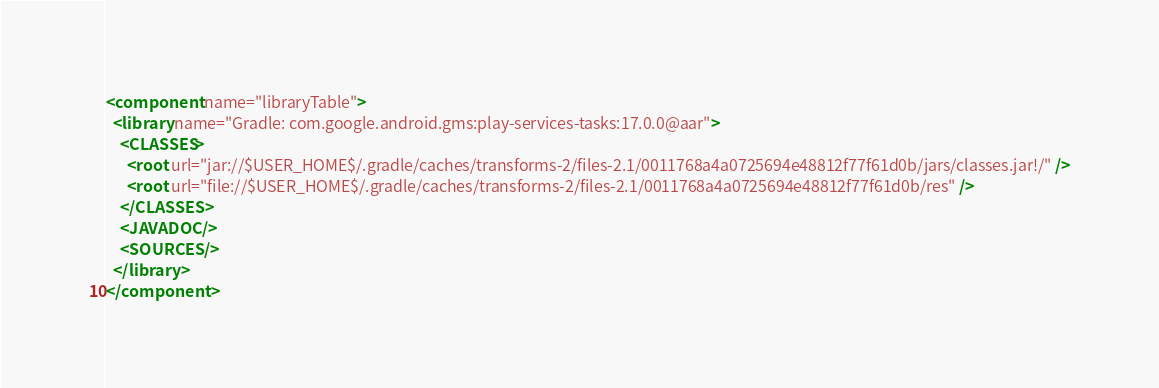Convert code to text. <code><loc_0><loc_0><loc_500><loc_500><_XML_><component name="libraryTable">
  <library name="Gradle: com.google.android.gms:play-services-tasks:17.0.0@aar">
    <CLASSES>
      <root url="jar://$USER_HOME$/.gradle/caches/transforms-2/files-2.1/0011768a4a0725694e48812f77f61d0b/jars/classes.jar!/" />
      <root url="file://$USER_HOME$/.gradle/caches/transforms-2/files-2.1/0011768a4a0725694e48812f77f61d0b/res" />
    </CLASSES>
    <JAVADOC />
    <SOURCES />
  </library>
</component></code> 